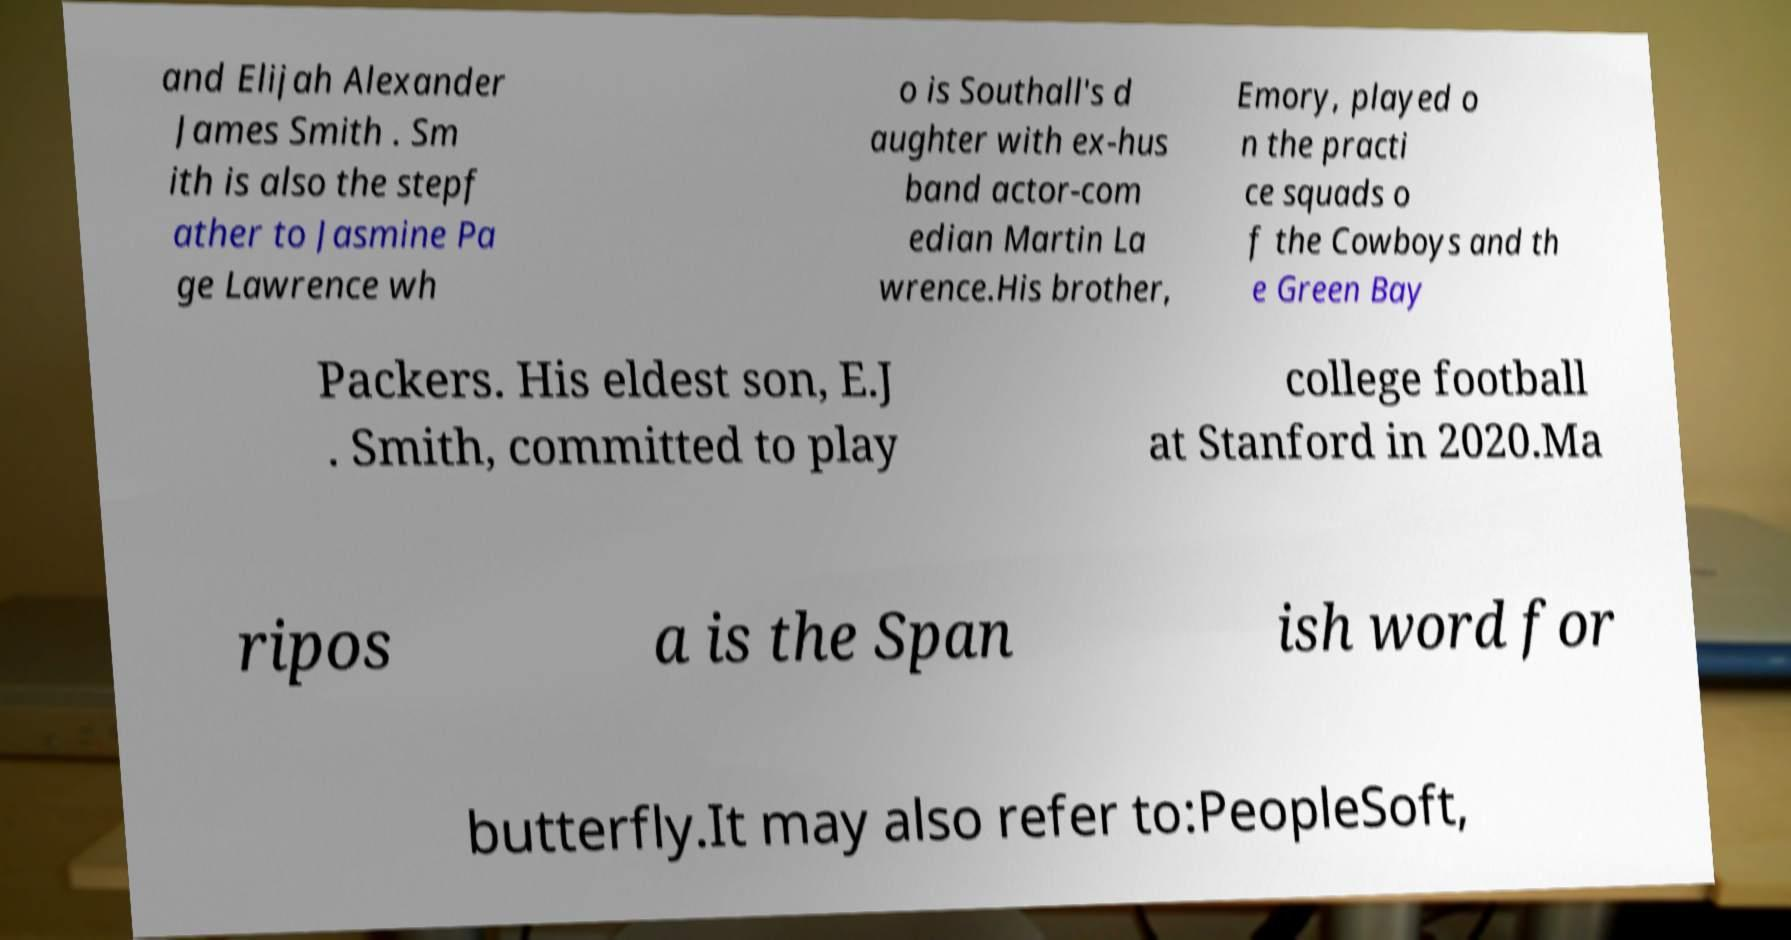Can you read and provide the text displayed in the image?This photo seems to have some interesting text. Can you extract and type it out for me? and Elijah Alexander James Smith . Sm ith is also the stepf ather to Jasmine Pa ge Lawrence wh o is Southall's d aughter with ex-hus band actor-com edian Martin La wrence.His brother, Emory, played o n the practi ce squads o f the Cowboys and th e Green Bay Packers. His eldest son, E.J . Smith, committed to play college football at Stanford in 2020.Ma ripos a is the Span ish word for butterfly.It may also refer to:PeopleSoft, 